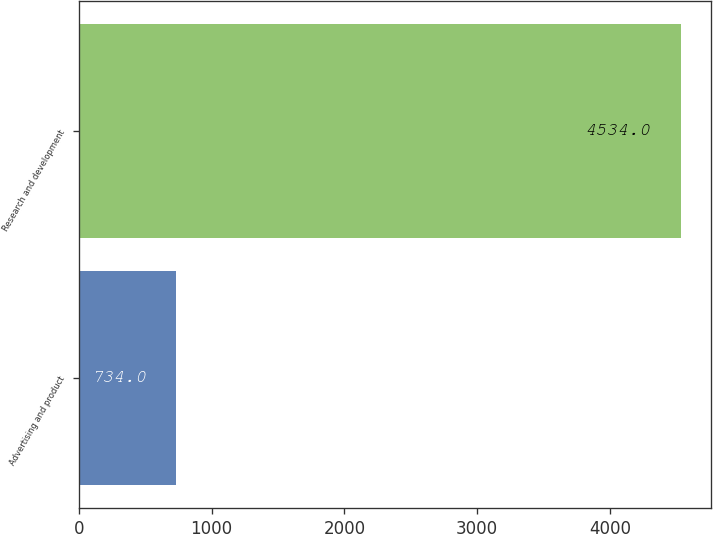Convert chart to OTSL. <chart><loc_0><loc_0><loc_500><loc_500><bar_chart><fcel>Advertising and product<fcel>Research and development<nl><fcel>734<fcel>4534<nl></chart> 